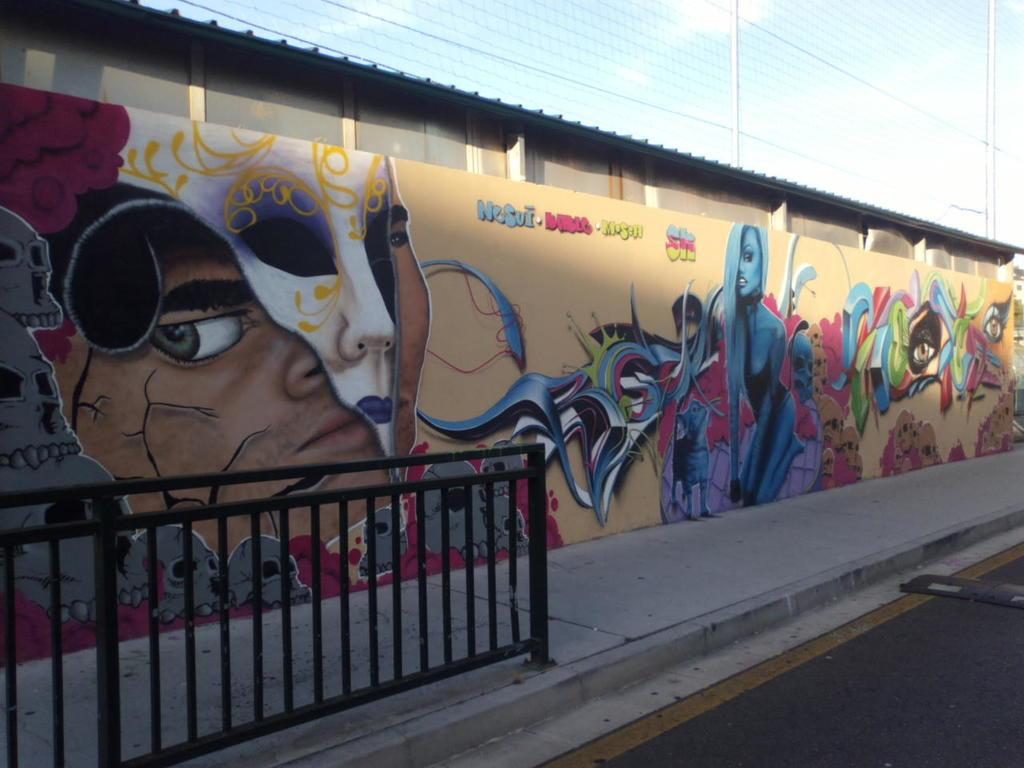What is on the wall in the image? There is a painting on the wall in the image. What does the painting depict? The painting depicts people and other things. What other object can be seen in the image? There is a fence in the image. What can be seen in the background of the image? The sky is visible in the background of the image. What type of humor is being expressed in the painting? There is no humor present in the painting; it depicts people and other things. Can you tell me the value of the vase in the image? There is no vase present in the image. 